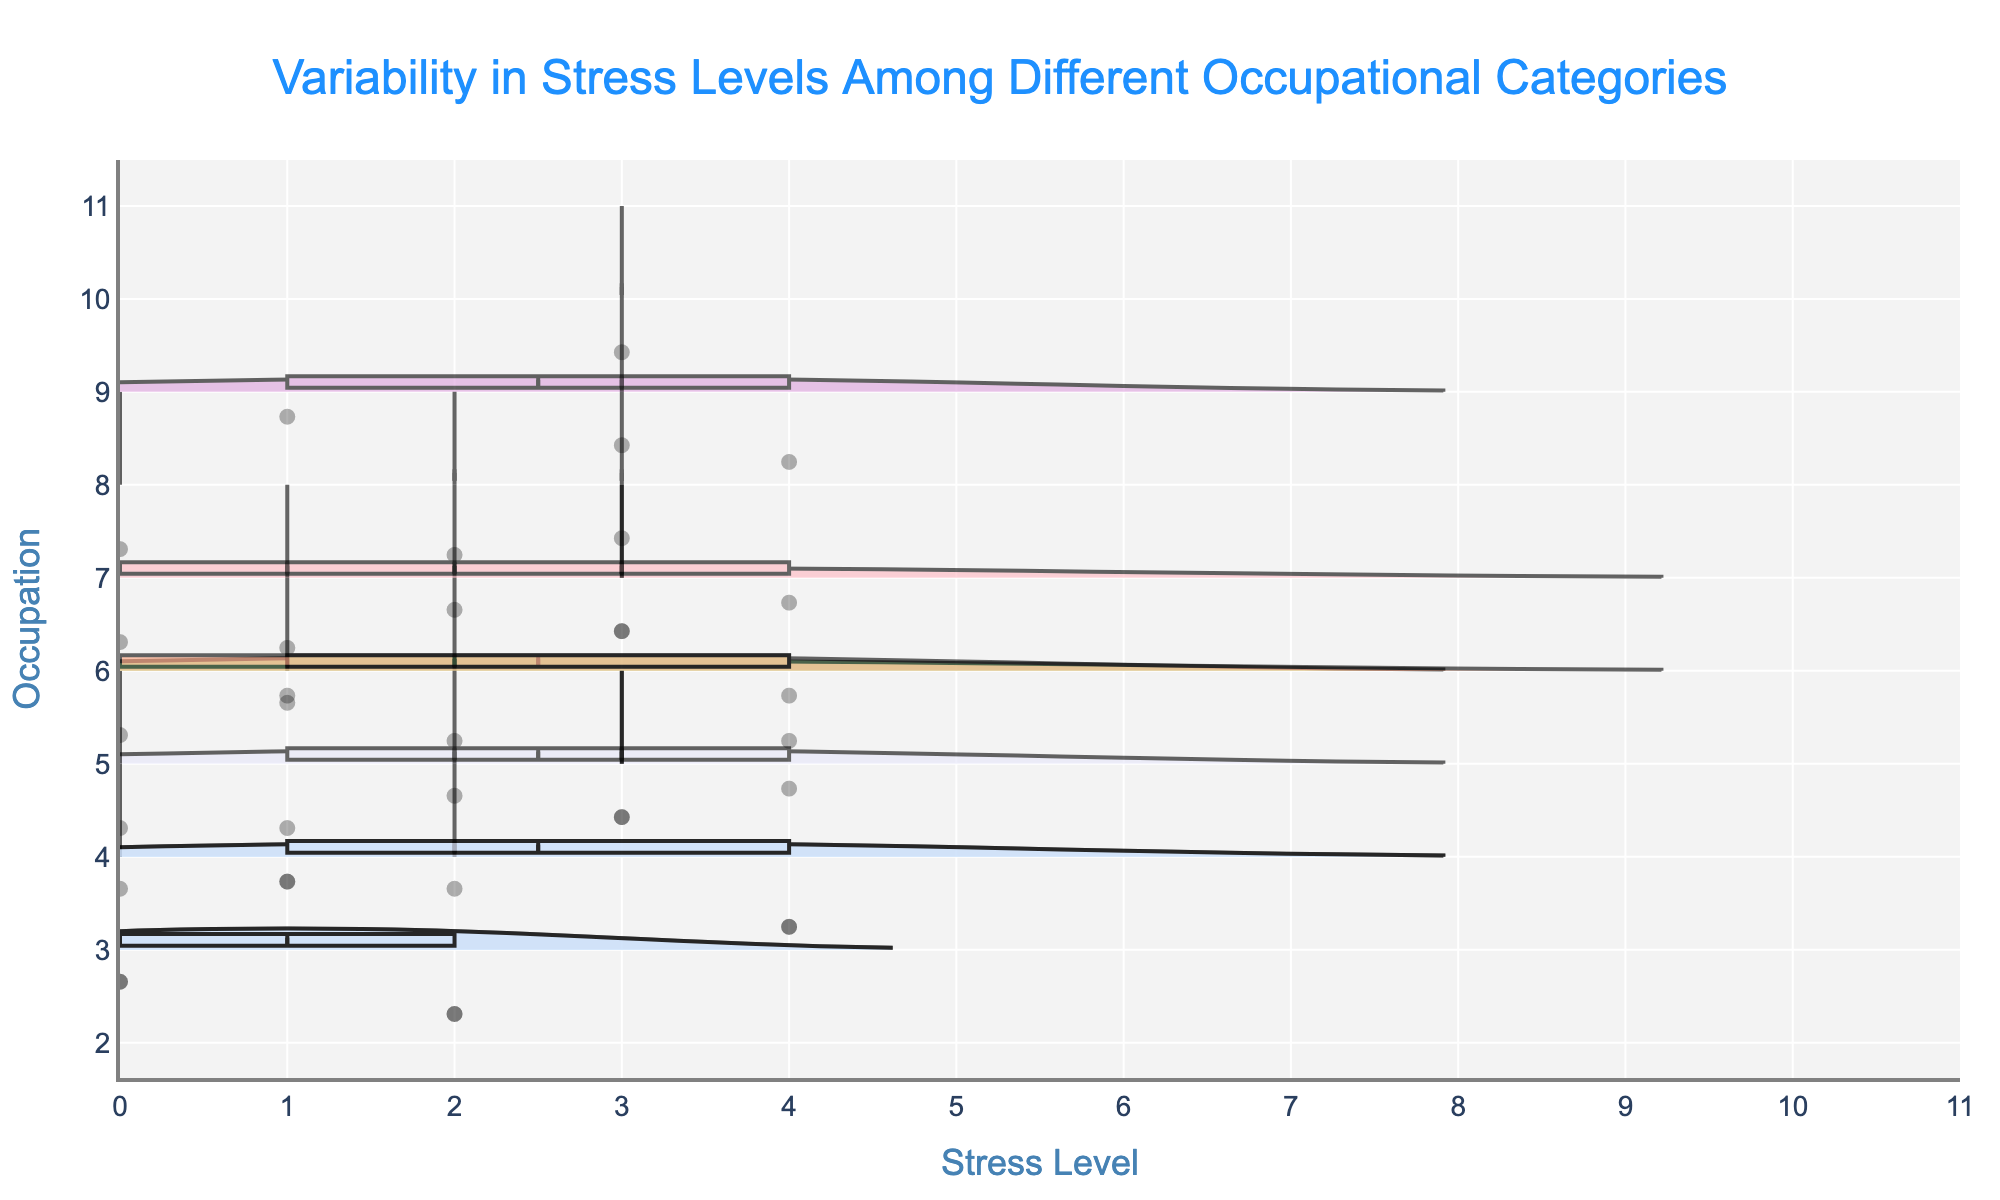How many occupations are represented in the chart? The plot includes one violin chart for each occupation. By counting the number of violin plots, we can determine the number of occupations.
Answer: Six Which occupation has the widest spread in stress levels? The width of the violin plot indicates the spread of stress levels for each occupation. The occupation with the widest violin plot has the highest variability in stress levels.
Answer: Nurse What is the median stress level for police officers? The median stress level is indicated by the horizontal line within the violin plot box. For police officers, the median can be directly read from this line.
Answer: 7 Compare the average stress level of nurses and teachers. Which is higher? The average stress level for each occupation is indicated by the meanline. By comparing the positions of these meanlines in the violin plots for nurses and teachers, we can determine which is higher.
Answer: Nurse Which occupation shows the least variability in stress levels? The violin plot with the least spread (narrowest width) indicates the lowest variability in stress levels.
Answer: Accountant What is the range of stress levels for bus drivers? The range is the difference between the maximum and minimum stress levels. For bus drivers, this can be observed from the endpoints of the violin plot.
Answer: 3 Rank the occupations based on their median stress levels from highest to lowest. Observing the median lines in each violin plot, we can rank the occupations.
Answer: Nurse > Police Officer > Bus Driver > Retail Worker > Teacher > Software Engineer = Accountant For which occupation do the minimum and maximum stress levels both lie within a narrower interval (not the full y-axis range)? We need to observe which occupation's violin plot stretches less far out from its center to its endpoints.
Answer: Accountant Is there any occupation where all stress levels are identical? If an occupation had all identical stress levels, its violin plot would appear as a single line without any spread. None of the violin plots appear that way, indicating that stress levels vary within each occupation.
Answer: No 